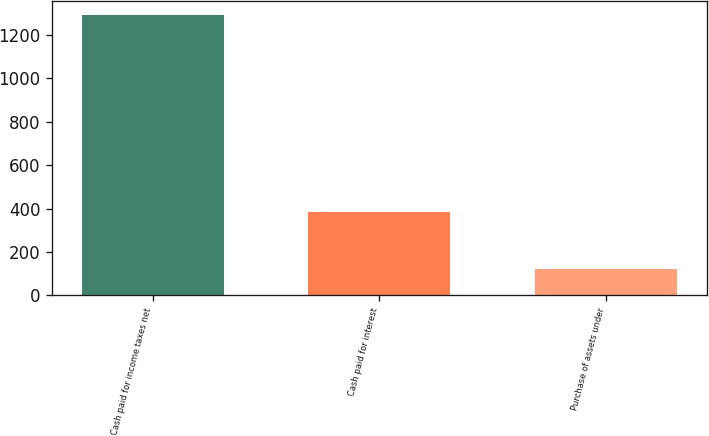Convert chart. <chart><loc_0><loc_0><loc_500><loc_500><bar_chart><fcel>Cash paid for income taxes net<fcel>Cash paid for interest<fcel>Purchase of assets under<nl><fcel>1293<fcel>384<fcel>122<nl></chart> 